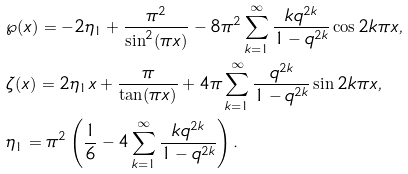Convert formula to latex. <formula><loc_0><loc_0><loc_500><loc_500>& \wp ( x ) = - 2 \eta _ { 1 } + \frac { \pi ^ { 2 } } { \sin ^ { 2 } ( \pi x ) } - 8 \pi ^ { 2 } \sum _ { k = 1 } ^ { \infty } \frac { k q ^ { 2 k } } { 1 - q ^ { 2 k } } \cos 2 k \pi x , \\ & \zeta ( x ) = 2 \eta _ { 1 } x + \frac { \pi } { \tan ( \pi x ) } + 4 \pi \sum _ { k = 1 } ^ { \infty } \frac { q ^ { 2 k } } { 1 - q ^ { 2 k } } \sin 2 k \pi x , \\ & \eta _ { 1 } = \pi ^ { 2 } \left ( \frac { 1 } { 6 } - 4 \sum _ { k = 1 } ^ { \infty } \frac { k q ^ { 2 k } } { 1 - q ^ { 2 k } } \right ) .</formula> 